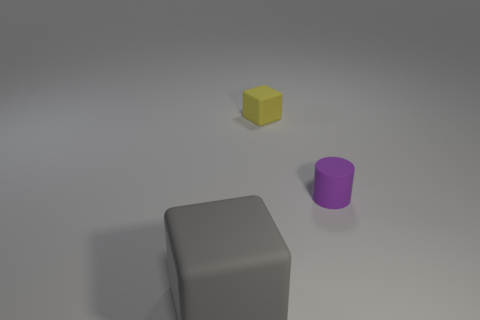Are there any other things that have the same size as the gray matte cube?
Offer a terse response. No. Do the yellow object and the purple cylinder have the same size?
Ensure brevity in your answer.  Yes. Are there fewer big gray objects right of the tiny purple matte cylinder than small blocks left of the gray block?
Offer a terse response. No. The yellow matte thing is what size?
Your response must be concise. Small. How many small things are either gray objects or purple rubber blocks?
Provide a short and direct response. 0. There is a purple object; is its size the same as the block that is behind the tiny purple matte object?
Keep it short and to the point. Yes. Are there any other things that are the same shape as the gray object?
Offer a terse response. Yes. How many cylinders are there?
Offer a very short reply. 1. How many yellow objects are large things or rubber blocks?
Your answer should be compact. 1. Is the material of the cube that is on the right side of the large thing the same as the large cube?
Offer a terse response. Yes. 